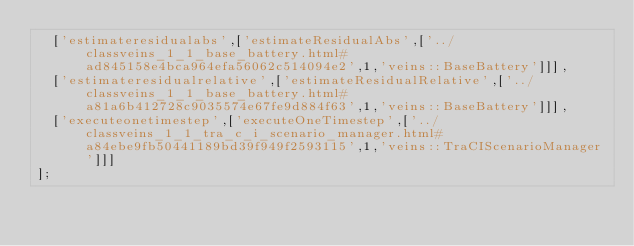<code> <loc_0><loc_0><loc_500><loc_500><_JavaScript_>  ['estimateresidualabs',['estimateResidualAbs',['../classveins_1_1_base_battery.html#ad845158e4bca964efa56062c514094e2',1,'veins::BaseBattery']]],
  ['estimateresidualrelative',['estimateResidualRelative',['../classveins_1_1_base_battery.html#a81a6b412728c9035574e67fe9d884f63',1,'veins::BaseBattery']]],
  ['executeonetimestep',['executeOneTimestep',['../classveins_1_1_tra_c_i_scenario_manager.html#a84ebe9fb50441189bd39f949f2593115',1,'veins::TraCIScenarioManager']]]
];
</code> 